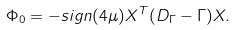Convert formula to latex. <formula><loc_0><loc_0><loc_500><loc_500>\Phi _ { 0 } = - s i g n ( 4 \mu ) X ^ { T } ( D _ { \Gamma } - \Gamma ) X .</formula> 